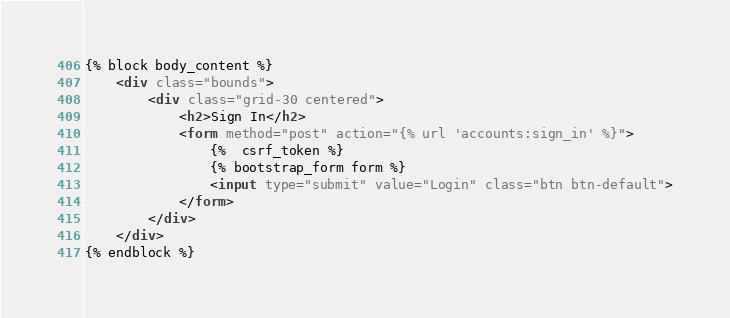Convert code to text. <code><loc_0><loc_0><loc_500><loc_500><_HTML_>
{% block body_content %}
    <div class="bounds">
        <div class="grid-30 centered">
            <h2>Sign In</h2>
            <form method="post" action="{% url 'accounts:sign_in' %}">
                {%  csrf_token %}
                {% bootstrap_form form %}
                <input type="submit" value="Login" class="btn btn-default">
            </form>
        </div>
    </div>
{% endblock %}
</code> 